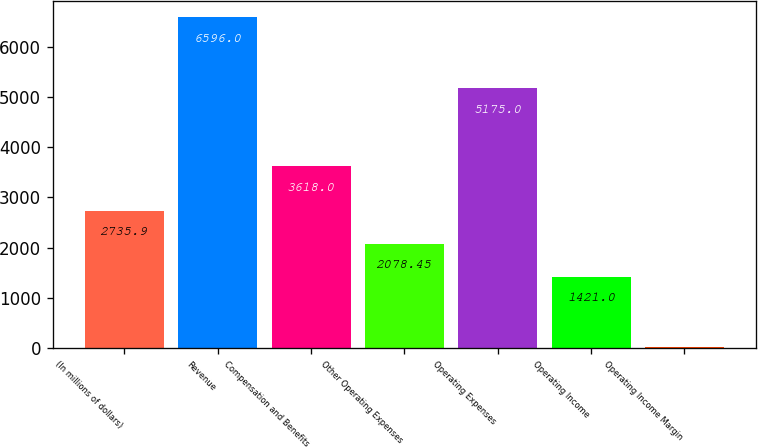Convert chart. <chart><loc_0><loc_0><loc_500><loc_500><bar_chart><fcel>(In millions of dollars)<fcel>Revenue<fcel>Compensation and Benefits<fcel>Other Operating Expenses<fcel>Operating Expenses<fcel>Operating Income<fcel>Operating Income Margin<nl><fcel>2735.9<fcel>6596<fcel>3618<fcel>2078.45<fcel>5175<fcel>1421<fcel>21.5<nl></chart> 